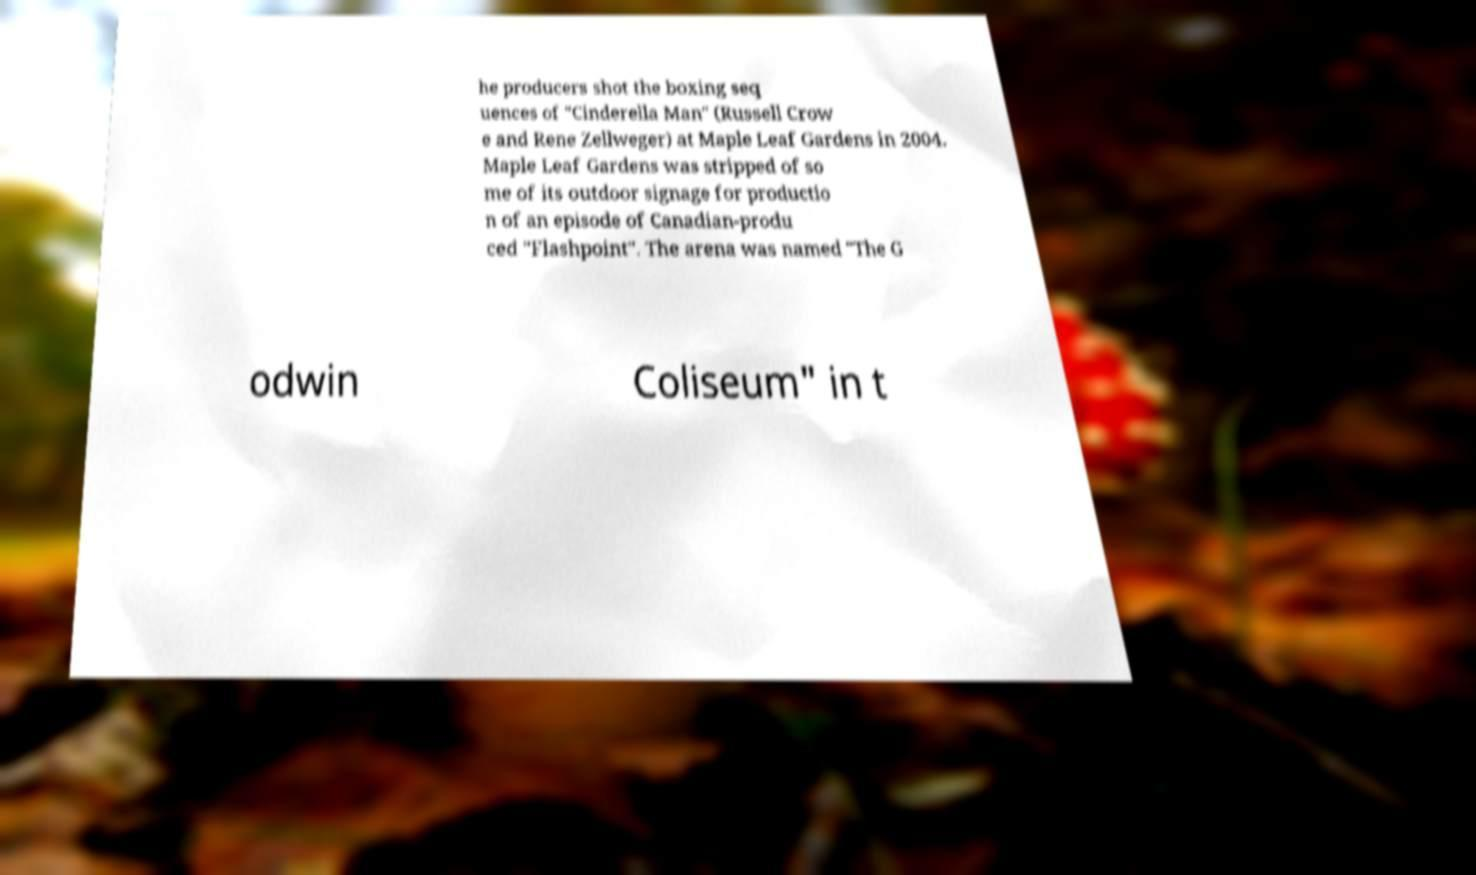Could you extract and type out the text from this image? he producers shot the boxing seq uences of "Cinderella Man" (Russell Crow e and Rene Zellweger) at Maple Leaf Gardens in 2004. Maple Leaf Gardens was stripped of so me of its outdoor signage for productio n of an episode of Canadian-produ ced "Flashpoint". The arena was named "The G odwin Coliseum" in t 